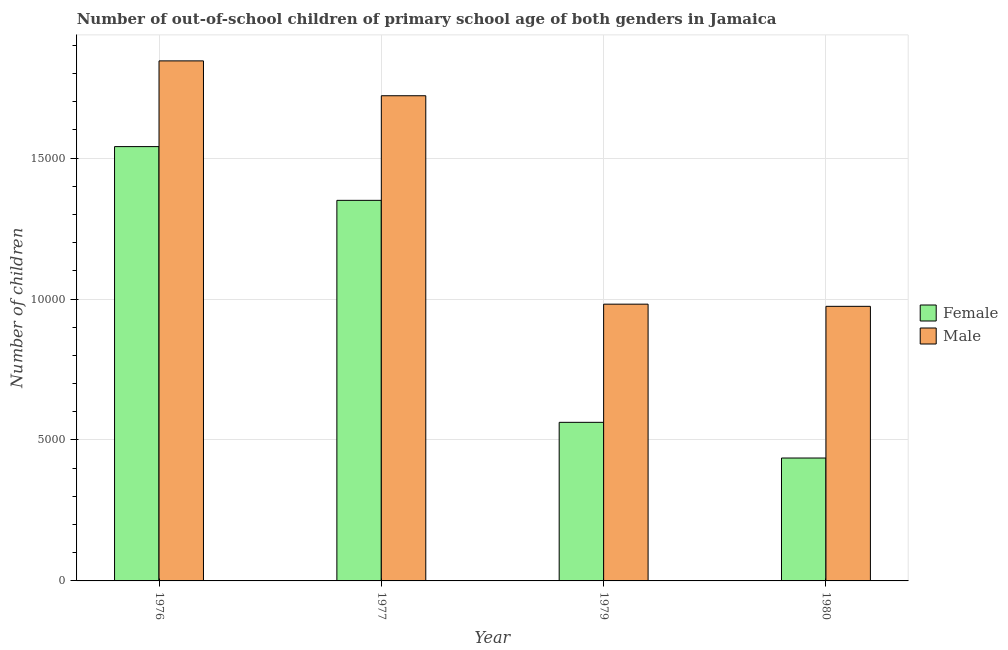How many different coloured bars are there?
Offer a very short reply. 2. How many groups of bars are there?
Your response must be concise. 4. Are the number of bars per tick equal to the number of legend labels?
Your response must be concise. Yes. Are the number of bars on each tick of the X-axis equal?
Provide a succinct answer. Yes. What is the label of the 2nd group of bars from the left?
Your answer should be very brief. 1977. In how many cases, is the number of bars for a given year not equal to the number of legend labels?
Ensure brevity in your answer.  0. What is the number of male out-of-school students in 1980?
Provide a short and direct response. 9741. Across all years, what is the maximum number of female out-of-school students?
Offer a terse response. 1.54e+04. Across all years, what is the minimum number of male out-of-school students?
Keep it short and to the point. 9741. In which year was the number of female out-of-school students maximum?
Your answer should be compact. 1976. In which year was the number of male out-of-school students minimum?
Keep it short and to the point. 1980. What is the total number of male out-of-school students in the graph?
Keep it short and to the point. 5.52e+04. What is the difference between the number of female out-of-school students in 1976 and that in 1977?
Offer a terse response. 1907. What is the difference between the number of female out-of-school students in 1976 and the number of male out-of-school students in 1979?
Offer a terse response. 9782. What is the average number of male out-of-school students per year?
Your answer should be compact. 1.38e+04. In the year 1979, what is the difference between the number of female out-of-school students and number of male out-of-school students?
Provide a short and direct response. 0. What is the ratio of the number of female out-of-school students in 1977 to that in 1979?
Your answer should be very brief. 2.4. Is the number of male out-of-school students in 1979 less than that in 1980?
Provide a short and direct response. No. Is the difference between the number of male out-of-school students in 1976 and 1979 greater than the difference between the number of female out-of-school students in 1976 and 1979?
Give a very brief answer. No. What is the difference between the highest and the second highest number of female out-of-school students?
Provide a short and direct response. 1907. What is the difference between the highest and the lowest number of male out-of-school students?
Offer a very short reply. 8708. How many years are there in the graph?
Give a very brief answer. 4. Are the values on the major ticks of Y-axis written in scientific E-notation?
Provide a succinct answer. No. Does the graph contain any zero values?
Provide a succinct answer. No. Does the graph contain grids?
Offer a very short reply. Yes. Where does the legend appear in the graph?
Provide a succinct answer. Center right. What is the title of the graph?
Provide a succinct answer. Number of out-of-school children of primary school age of both genders in Jamaica. What is the label or title of the Y-axis?
Offer a terse response. Number of children. What is the Number of children in Female in 1976?
Provide a succinct answer. 1.54e+04. What is the Number of children of Male in 1976?
Ensure brevity in your answer.  1.84e+04. What is the Number of children of Female in 1977?
Ensure brevity in your answer.  1.35e+04. What is the Number of children in Male in 1977?
Offer a very short reply. 1.72e+04. What is the Number of children in Female in 1979?
Offer a terse response. 5626. What is the Number of children of Male in 1979?
Provide a succinct answer. 9818. What is the Number of children of Female in 1980?
Your answer should be compact. 4360. What is the Number of children of Male in 1980?
Your answer should be very brief. 9741. Across all years, what is the maximum Number of children of Female?
Provide a succinct answer. 1.54e+04. Across all years, what is the maximum Number of children of Male?
Your answer should be compact. 1.84e+04. Across all years, what is the minimum Number of children of Female?
Give a very brief answer. 4360. Across all years, what is the minimum Number of children in Male?
Provide a short and direct response. 9741. What is the total Number of children of Female in the graph?
Your answer should be very brief. 3.89e+04. What is the total Number of children of Male in the graph?
Your response must be concise. 5.52e+04. What is the difference between the Number of children of Female in 1976 and that in 1977?
Offer a terse response. 1907. What is the difference between the Number of children in Male in 1976 and that in 1977?
Offer a very short reply. 1237. What is the difference between the Number of children of Female in 1976 and that in 1979?
Provide a succinct answer. 9782. What is the difference between the Number of children in Male in 1976 and that in 1979?
Offer a terse response. 8631. What is the difference between the Number of children of Female in 1976 and that in 1980?
Make the answer very short. 1.10e+04. What is the difference between the Number of children of Male in 1976 and that in 1980?
Offer a very short reply. 8708. What is the difference between the Number of children in Female in 1977 and that in 1979?
Provide a succinct answer. 7875. What is the difference between the Number of children in Male in 1977 and that in 1979?
Offer a very short reply. 7394. What is the difference between the Number of children of Female in 1977 and that in 1980?
Your answer should be very brief. 9141. What is the difference between the Number of children of Male in 1977 and that in 1980?
Provide a succinct answer. 7471. What is the difference between the Number of children of Female in 1979 and that in 1980?
Your answer should be very brief. 1266. What is the difference between the Number of children of Female in 1976 and the Number of children of Male in 1977?
Make the answer very short. -1804. What is the difference between the Number of children in Female in 1976 and the Number of children in Male in 1979?
Your answer should be very brief. 5590. What is the difference between the Number of children of Female in 1976 and the Number of children of Male in 1980?
Ensure brevity in your answer.  5667. What is the difference between the Number of children of Female in 1977 and the Number of children of Male in 1979?
Provide a succinct answer. 3683. What is the difference between the Number of children of Female in 1977 and the Number of children of Male in 1980?
Keep it short and to the point. 3760. What is the difference between the Number of children in Female in 1979 and the Number of children in Male in 1980?
Ensure brevity in your answer.  -4115. What is the average Number of children of Female per year?
Your response must be concise. 9723.75. What is the average Number of children of Male per year?
Your answer should be compact. 1.38e+04. In the year 1976, what is the difference between the Number of children in Female and Number of children in Male?
Your answer should be compact. -3041. In the year 1977, what is the difference between the Number of children in Female and Number of children in Male?
Your answer should be compact. -3711. In the year 1979, what is the difference between the Number of children in Female and Number of children in Male?
Your answer should be compact. -4192. In the year 1980, what is the difference between the Number of children in Female and Number of children in Male?
Offer a terse response. -5381. What is the ratio of the Number of children of Female in 1976 to that in 1977?
Offer a very short reply. 1.14. What is the ratio of the Number of children of Male in 1976 to that in 1977?
Provide a short and direct response. 1.07. What is the ratio of the Number of children of Female in 1976 to that in 1979?
Ensure brevity in your answer.  2.74. What is the ratio of the Number of children in Male in 1976 to that in 1979?
Give a very brief answer. 1.88. What is the ratio of the Number of children of Female in 1976 to that in 1980?
Provide a short and direct response. 3.53. What is the ratio of the Number of children in Male in 1976 to that in 1980?
Make the answer very short. 1.89. What is the ratio of the Number of children in Female in 1977 to that in 1979?
Offer a very short reply. 2.4. What is the ratio of the Number of children of Male in 1977 to that in 1979?
Give a very brief answer. 1.75. What is the ratio of the Number of children of Female in 1977 to that in 1980?
Ensure brevity in your answer.  3.1. What is the ratio of the Number of children of Male in 1977 to that in 1980?
Keep it short and to the point. 1.77. What is the ratio of the Number of children of Female in 1979 to that in 1980?
Make the answer very short. 1.29. What is the ratio of the Number of children in Male in 1979 to that in 1980?
Provide a succinct answer. 1.01. What is the difference between the highest and the second highest Number of children in Female?
Give a very brief answer. 1907. What is the difference between the highest and the second highest Number of children of Male?
Your response must be concise. 1237. What is the difference between the highest and the lowest Number of children in Female?
Offer a terse response. 1.10e+04. What is the difference between the highest and the lowest Number of children in Male?
Offer a very short reply. 8708. 